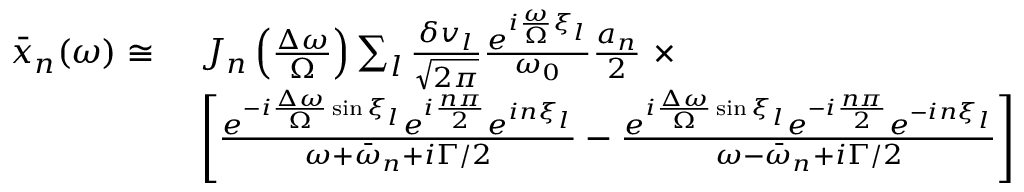Convert formula to latex. <formula><loc_0><loc_0><loc_500><loc_500>\begin{array} { r l } { \bar { x } _ { n } ( \omega ) \cong \ } & { J _ { n } \left ( \frac { \Delta \omega } { \Omega } \right ) \sum _ { l } \frac { \delta v _ { l } } { \sqrt { 2 \pi } } \frac { e ^ { i \frac { \omega } { \Omega } \xi _ { l } } } { \omega _ { 0 } } \frac { a _ { n } } { 2 } \ \times } \\ & { \left [ \frac { e ^ { - i \frac { \Delta \omega } { \Omega } \sin { \xi _ { l } } } e ^ { i \frac { n \pi } { 2 } } e ^ { i n \xi _ { l } } } { \omega + \bar { \omega } _ { n } + i \Gamma / 2 } - \frac { e ^ { i \frac { \Delta \omega } { \Omega } \sin { \xi _ { l } } } e ^ { - i \frac { n \pi } { 2 } } e ^ { - i n \xi _ { l } } } { \omega - \bar { \omega } _ { n } + i \Gamma / 2 } \right ] } \end{array}</formula> 